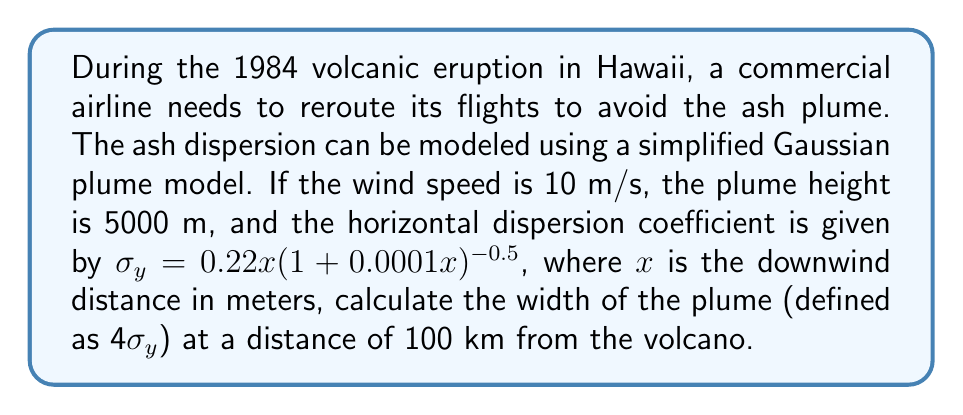Provide a solution to this math problem. To solve this problem, we need to follow these steps:

1. Identify the given information:
   - Wind speed: 10 m/s
   - Plume height: 5000 m
   - Horizontal dispersion coefficient: $\sigma_y = 0.22x(1 + 0.0001x)^{-0.5}$
   - Downwind distance: 100 km = 100,000 m

2. Calculate $\sigma_y$ at 100 km:
   $$\sigma_y = 0.22 \cdot 100000 \cdot (1 + 0.0001 \cdot 100000)^{-0.5}$$
   $$\sigma_y = 22000 \cdot (1 + 10)^{-0.5}$$
   $$\sigma_y = 22000 \cdot (11)^{-0.5}$$
   $$\sigma_y = 22000 \cdot \frac{1}{\sqrt{11}}$$
   $$\sigma_y \approx 6631.23 \text{ m}$$

3. Calculate the width of the plume:
   The width is defined as 4$\sigma_y$, so:
   $$\text{Width} = 4 \cdot \sigma_y$$
   $$\text{Width} = 4 \cdot 6631.23$$
   $$\text{Width} \approx 26524.92 \text{ m}$$

4. Convert the result to kilometers:
   $$\text{Width} \approx 26.52 \text{ km}$$
Answer: The width of the volcanic ash plume at a distance of 100 km from the volcano is approximately 26.52 km. 